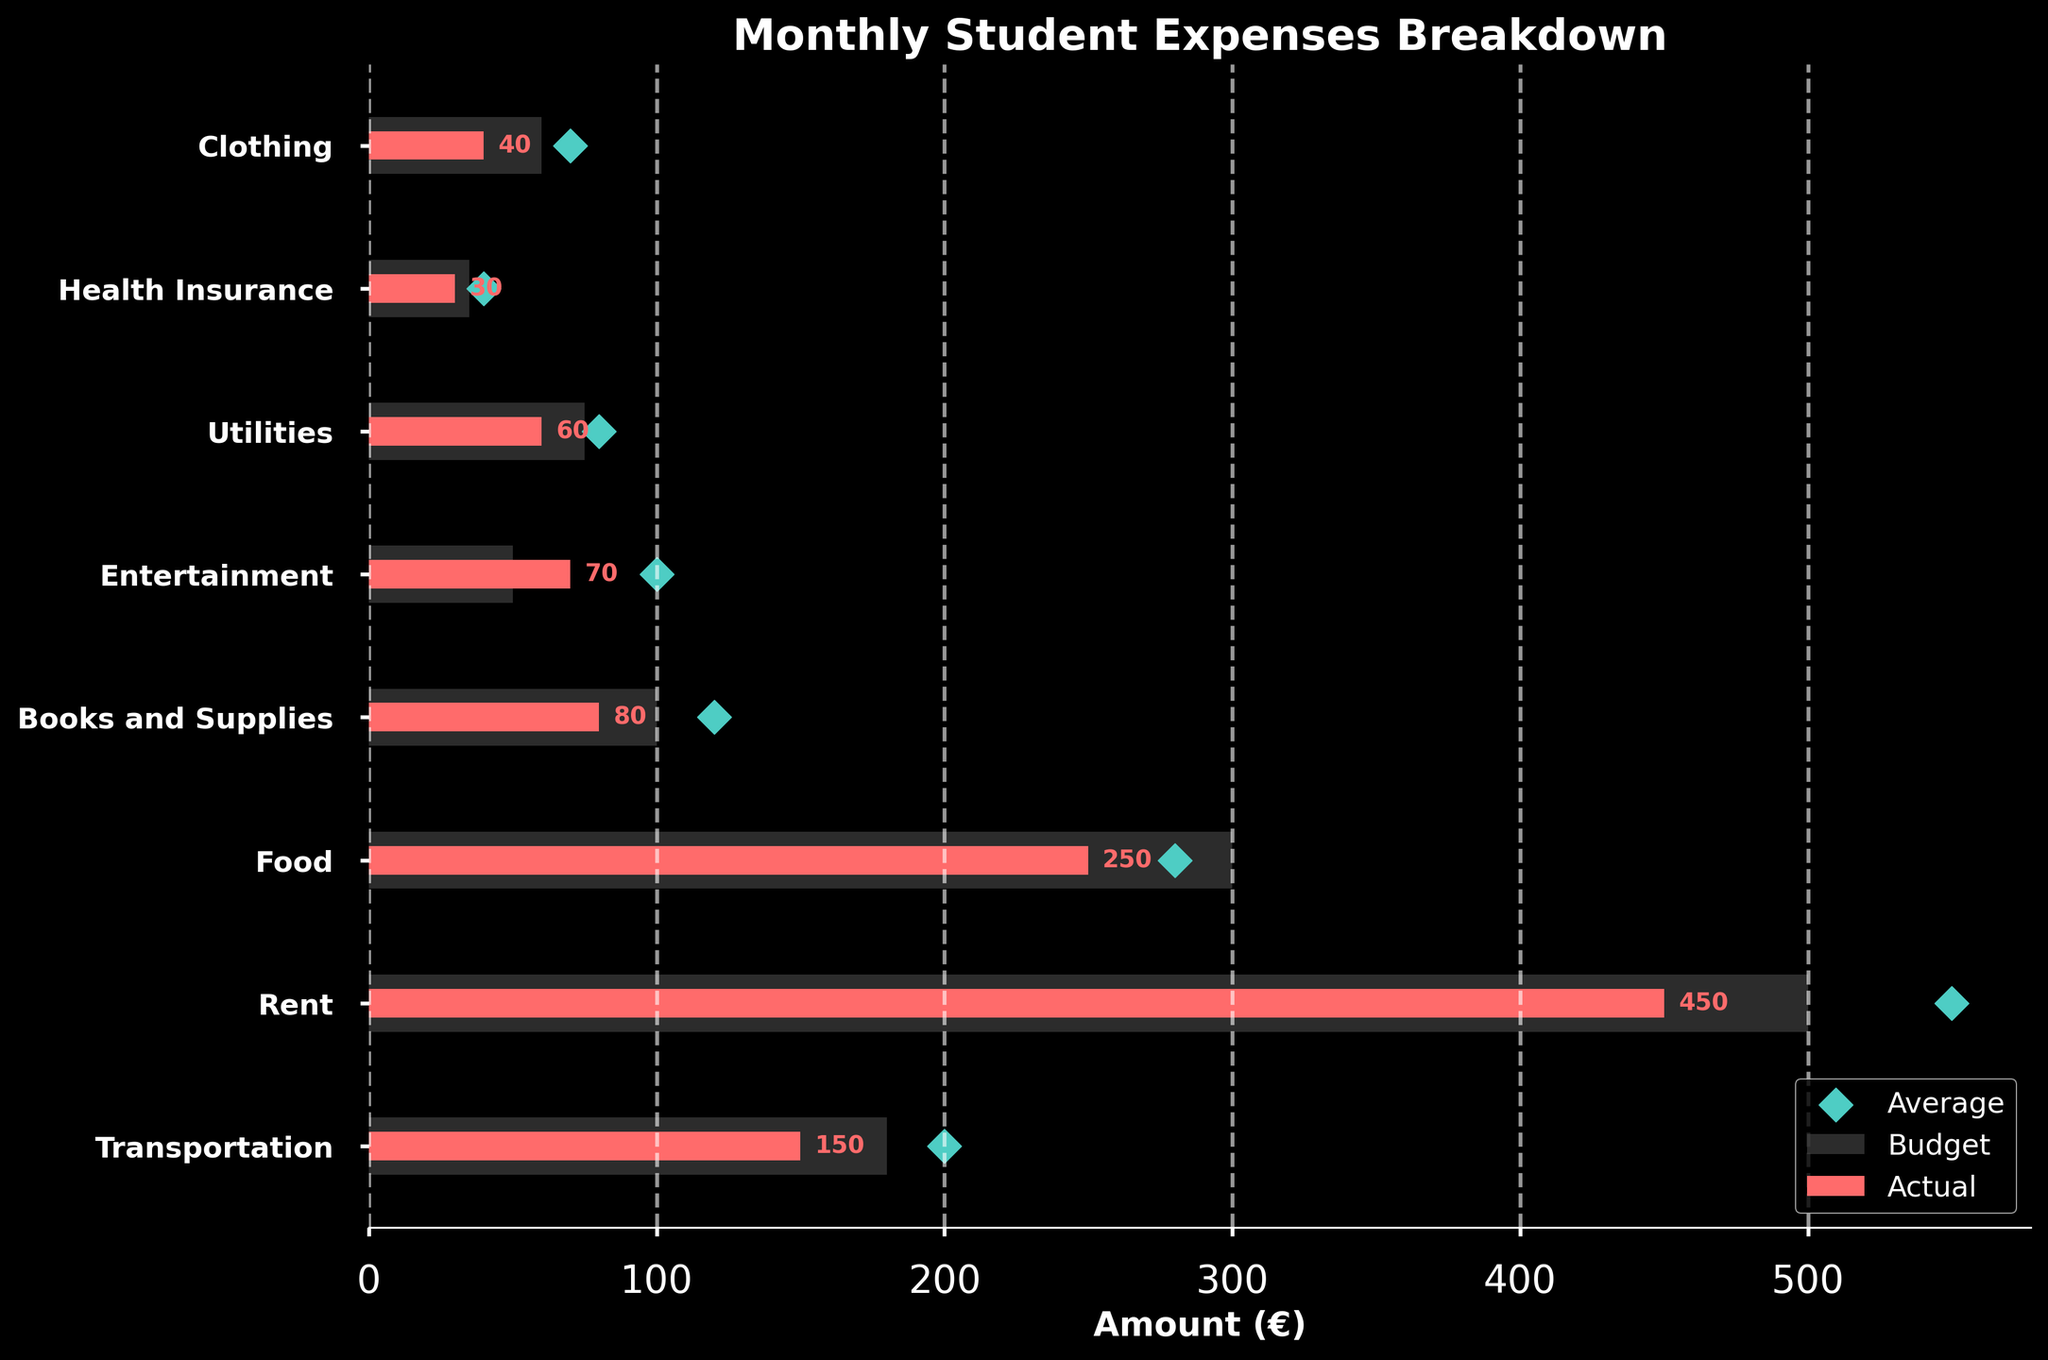What is the actual expense on food? Look at the 'Food' category and refer to the value marked in red (Actual), which is 250 euros.
Answer: 250 Which category has the highest budgeted expense? Compare all the budgeted values and find the maximum, which is in the 'Rent' category at 500 euros.
Answer: Rent How much more is spent on entertainment compared to the budget? Subtract the budgeted expense for entertainment (50 euros) from the actual expense (70 euros): 70 - 50 = 20 euros.
Answer: 20 What is the total budget for food, rent, and transportation? Sum the budgeted values for 'Food' (300 euros), 'Rent' (500 euros), and 'Transportation' (180 euros): 300 + 500 + 180 = 980 euros.
Answer: 980 Which category has the greatest difference between actual and average expenses? Calculate the differences between actual and average expenses for each category, and identify the greatest difference: 'Entertainment' with a difference of 100 - 70 = 30 euros.
Answer: Entertainment How is the actual rent expense compared to the average? Notice the red bar (Actual) and the green diamond (Average) for 'Rent'. The actual expense is 450 euros, which is less than the average of 550 euros.
Answer: Less What is the average expense on utilities? Refer to the green diamond for 'Utilities', which is marked at 80 euros.
Answer: 80 What is the difference between the highest average expense and the lowest average expense categories? Identify the highest average expense ('Rent' at 550 euros) and the lowest average expense ('Health Insurance' at 40 euros), and subtract: 550 - 40 = 510 euros.
Answer: 510 Among all categories, which one is closest to its budgeted value? Compare the actual and budgeted values for each category to find the smallest difference: 'Transportation' with an actual of 150 euros and a budget of 180 euros, a difference of 30 euros.
Answer: Transportation How much more is the average expense on books and supplies compared to transportation? Subtract the average expense for 'Transportation' (200 euros) from that of 'Books and Supplies' (120 euros): 200 - 120 = 80 euros.
Answer: 80 